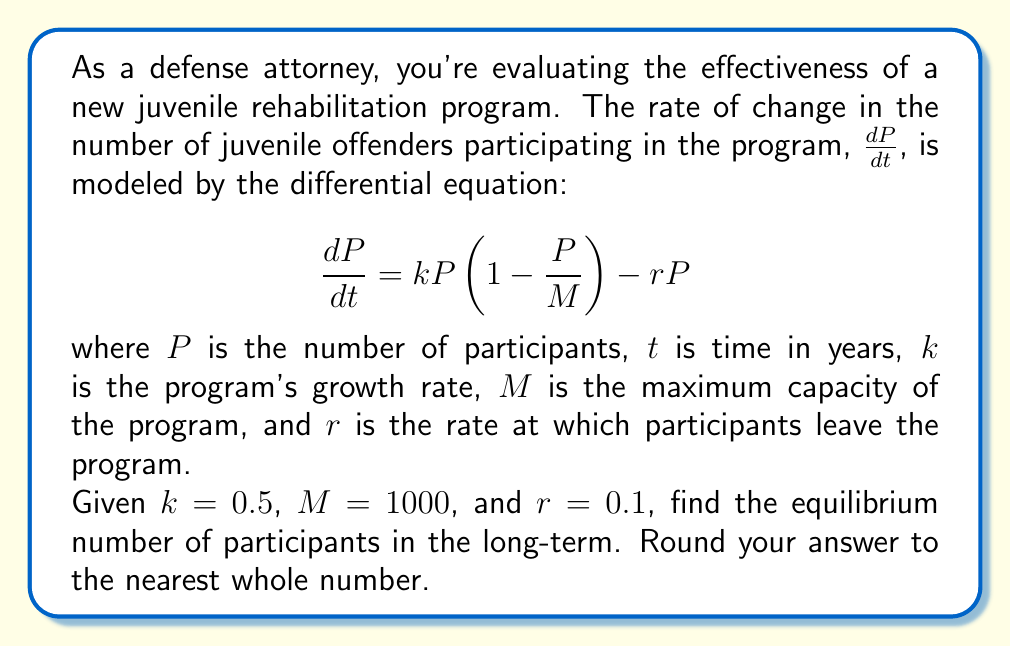Can you solve this math problem? To find the equilibrium number of participants, we need to solve for $P$ when $\frac{dP}{dt} = 0$:

1) Set the equation equal to zero:
   $$0 = kP(1 - \frac{P}{M}) - rP$$

2) Substitute the given values:
   $$0 = 0.5P(1 - \frac{P}{1000}) - 0.1P$$

3) Expand the equation:
   $$0 = 0.5P - \frac{0.5P^2}{1000} - 0.1P$$

4) Simplify:
   $$0 = 0.4P - \frac{0.5P^2}{1000}$$

5) Multiply both sides by 1000:
   $$0 = 400P - 0.5P^2$$

6) Rearrange to standard quadratic form:
   $$0.5P^2 - 400P = 0$$

7) Factor out P:
   $$P(0.5P - 400) = 0$$

8) Solve for P:
   $P = 0$ or $0.5P - 400 = 0$
   $P = 0$ or $P = 800$

9) Since $P = 0$ is trivial and doesn't represent a meaningful equilibrium for the program, we take $P = 800$.

10) Round to the nearest whole number: 800.

Therefore, the long-term equilibrium number of participants is 800.
Answer: 800 participants 